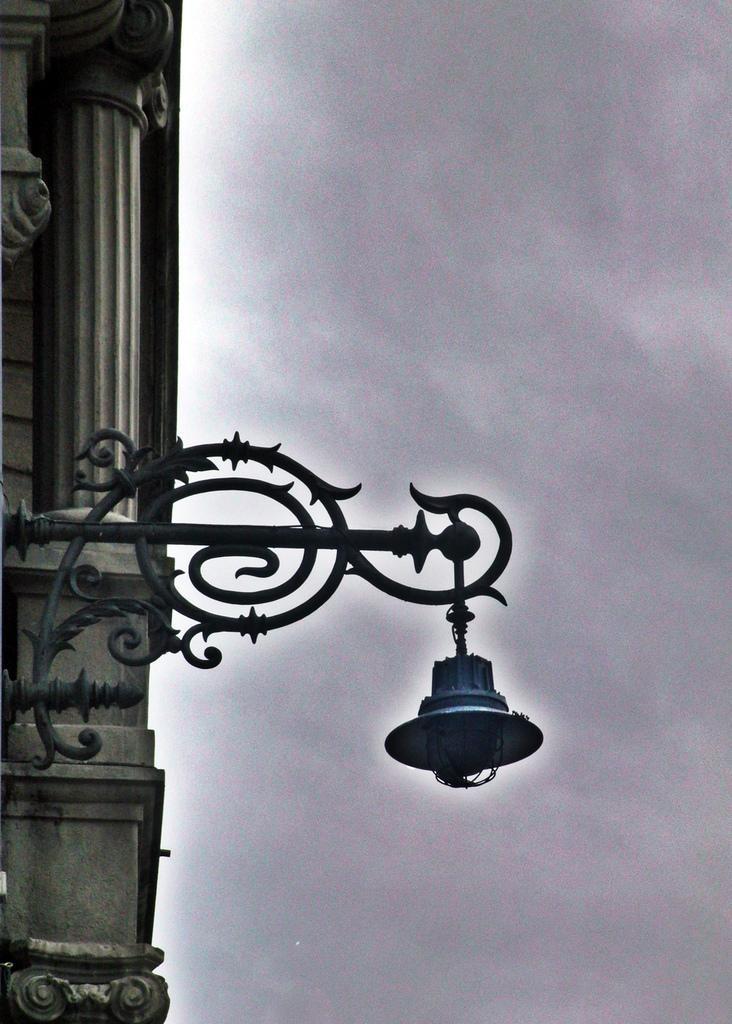Can you describe this image briefly? In this picture we can see a street light. Behind the street light, there is a pillar and the cloudy sky. 